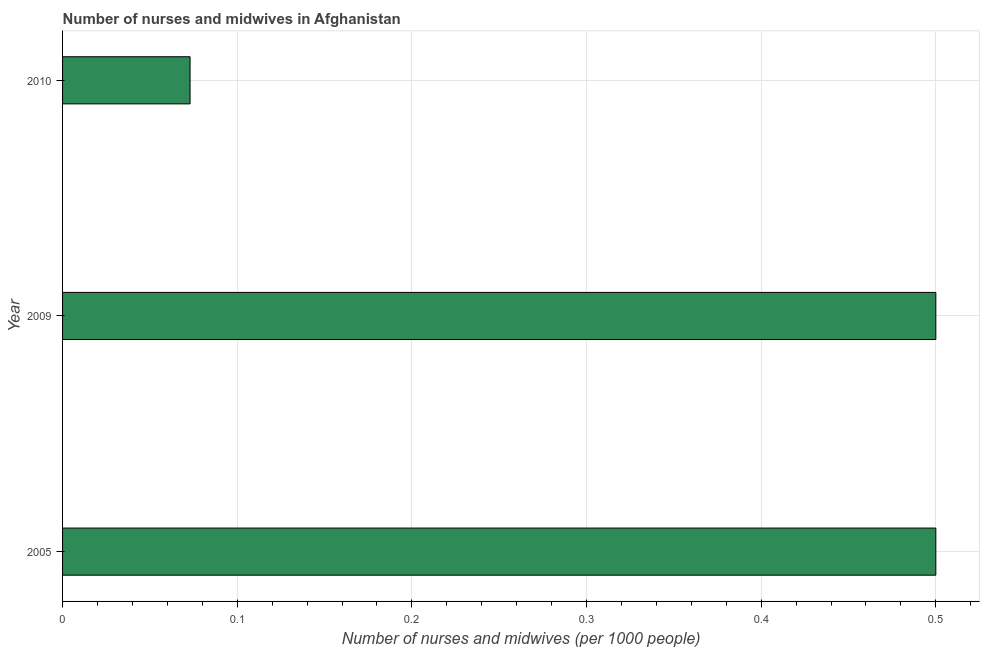Does the graph contain grids?
Provide a short and direct response. Yes. What is the title of the graph?
Give a very brief answer. Number of nurses and midwives in Afghanistan. What is the label or title of the X-axis?
Keep it short and to the point. Number of nurses and midwives (per 1000 people). What is the number of nurses and midwives in 2005?
Give a very brief answer. 0.5. Across all years, what is the minimum number of nurses and midwives?
Provide a succinct answer. 0.07. In which year was the number of nurses and midwives maximum?
Offer a terse response. 2005. In which year was the number of nurses and midwives minimum?
Provide a short and direct response. 2010. What is the sum of the number of nurses and midwives?
Your answer should be very brief. 1.07. What is the average number of nurses and midwives per year?
Provide a succinct answer. 0.36. What is the median number of nurses and midwives?
Make the answer very short. 0.5. Is the number of nurses and midwives in 2005 less than that in 2010?
Offer a terse response. No. What is the difference between the highest and the lowest number of nurses and midwives?
Offer a terse response. 0.43. How many bars are there?
Ensure brevity in your answer.  3. Are the values on the major ticks of X-axis written in scientific E-notation?
Keep it short and to the point. No. What is the Number of nurses and midwives (per 1000 people) in 2010?
Your answer should be very brief. 0.07. What is the difference between the Number of nurses and midwives (per 1000 people) in 2005 and 2009?
Your response must be concise. 0. What is the difference between the Number of nurses and midwives (per 1000 people) in 2005 and 2010?
Your response must be concise. 0.43. What is the difference between the Number of nurses and midwives (per 1000 people) in 2009 and 2010?
Keep it short and to the point. 0.43. What is the ratio of the Number of nurses and midwives (per 1000 people) in 2005 to that in 2009?
Your answer should be very brief. 1. What is the ratio of the Number of nurses and midwives (per 1000 people) in 2005 to that in 2010?
Keep it short and to the point. 6.85. What is the ratio of the Number of nurses and midwives (per 1000 people) in 2009 to that in 2010?
Offer a terse response. 6.85. 